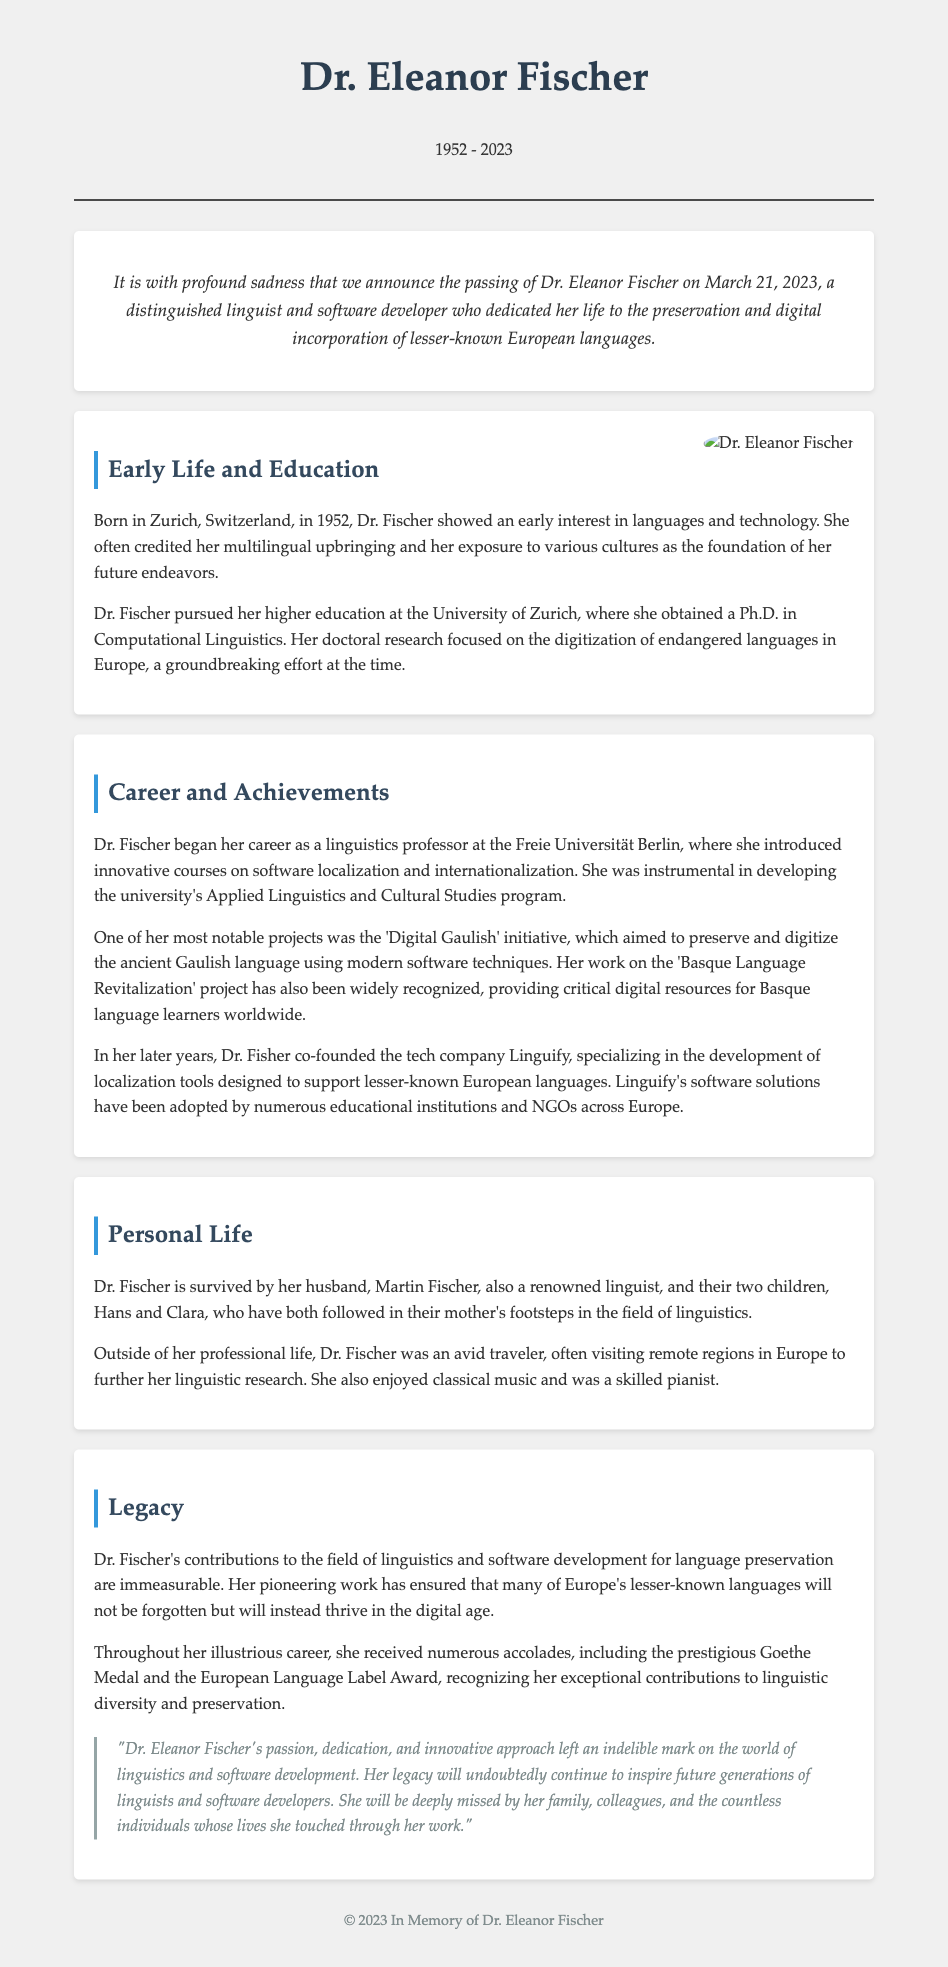What year was Dr. Eleanor Fischer born? The document states that Dr. Eleanor Fischer was born in 1952.
Answer: 1952 What notable project did Dr. Fischer work on related to the Gaulish language? The document mentions her involvement in the 'Digital Gaulish' initiative.
Answer: Digital Gaulish Who co-founded the tech company Linguify with Dr. Fischer? The document does not specify anyone else co-founded it; it solely mentions Dr. Fischer in this context.
Answer: No one mentioned What prestigious award did Dr. Fischer receive? The document lists the prestigious Goethe Medal as one of the accolades received by her.
Answer: Goethe Medal What field did Dr. Fischer obtain her Ph.D. in? The document indicates that she obtained her Ph.D. in Computational Linguistics.
Answer: Computational Linguistics What does the quote in the legacy section emphasize? The quote emphasizes Dr. Fischer's passion, dedication, and innovation in linguistics and software development.
Answer: Passion, dedication, innovation In which city was Dr. Eleanor Fischer born? The document states that she was born in Zurich, Switzerland.
Answer: Zurich What languages did Dr. Fischer focus on preserving? The document highlights her focus on lesser-known European languages.
Answer: Lesser-known European languages What position did Dr. Fischer hold at Freie Universität Berlin? The document mentions that she was a linguistics professor at the university.
Answer: Linguistics professor 